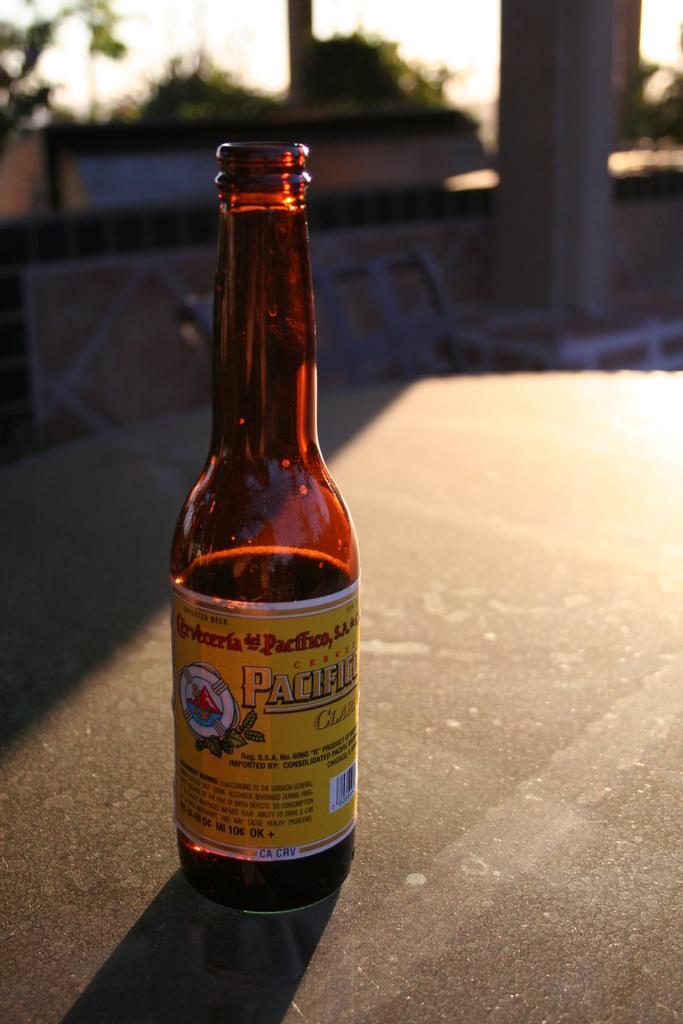<image>
Offer a succinct explanation of the picture presented. A bottle of Pacifico Beer sits on a table. 